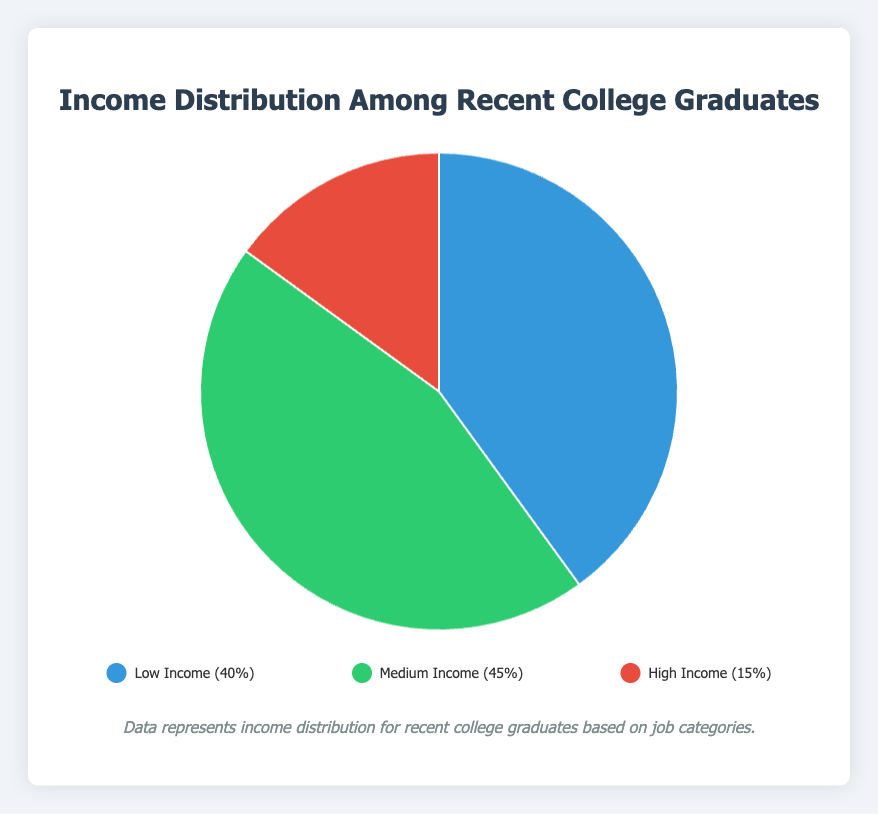What's the income category with the highest percentage among recent college graduates? By observing the pie chart, the green section labeled "Medium Income" is the largest slice, which corresponds to 45%.
Answer: Medium Income What is the combined percentage of low and high-income groups? From the pie chart, the low-income group is 40% and the high-income group is 15%. Adding these two values together: 40% + 15% = 55%.
Answer: 55% Which income category has the smallest percentage among recent college graduates? In the pie chart, the smallest slice is labeled "High Income," which is 15%.
Answer: High Income How much larger is the medium-income group compared to the high-income group? The medium-income group is 45%, and the high-income group is 15%. The difference between them is: 45% - 15% = 30%.
Answer: 30% What percentage of recent college graduates fall into a category that typically requires a bachelor's degree or higher? The medium income (bachelor's degree jobs) is 45%, and the high income (advanced degree or high-demand fields) is 15%. Adding them together gives: 45% + 15% = 60%.
Answer: 60% Which income category is represented by the red color in the pie chart? The legend indicates that the red color corresponds to the "High Income (15%)" category.
Answer: High Income If the total income distribution among recent college graduates is divided into two groups: low-income and others, what percentage falls under 'others'? The low-income group accounts for 40%, so the 'others' would be the sum of medium and high-income categories. Therefore, 45% (medium) + 15% (high) = 60%.
Answer: 60% Which income category is associated with examples like "Junior Software Developer" and "Financial Analyst"? According to the dataset details, these examples fall under the description of "Medium Income," which corresponds to the green section of the pie chart.
Answer: Medium Income What percentage is not covered by the medium-income group? The medium-income group is 45%, so the percentage not covered by it is: 100% - 45% = 55%.
Answer: 55% In the pie chart, what percentage do low and medium-income categories together form? Adding the percentages of low-income and medium-income groups: 40% + 45% = 85%.
Answer: 85% 